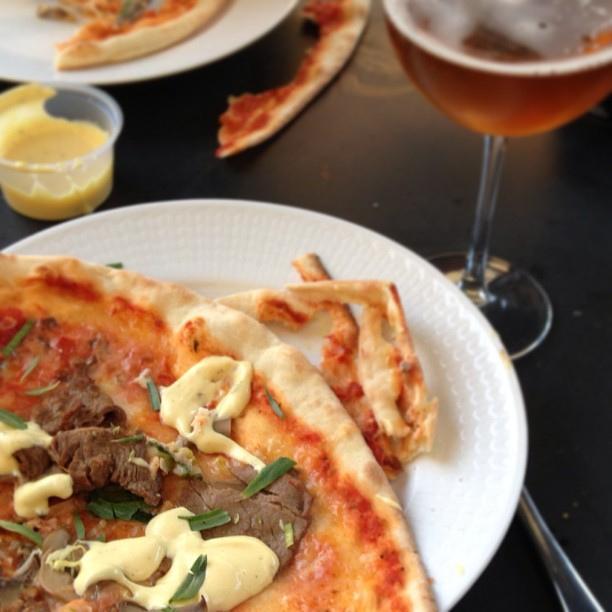Is the plates color green?
Answer briefly. No. What color is the liquid in the wine glass?
Keep it brief. Amber. Is there pepperoni on the pizza?
Keep it brief. No. 